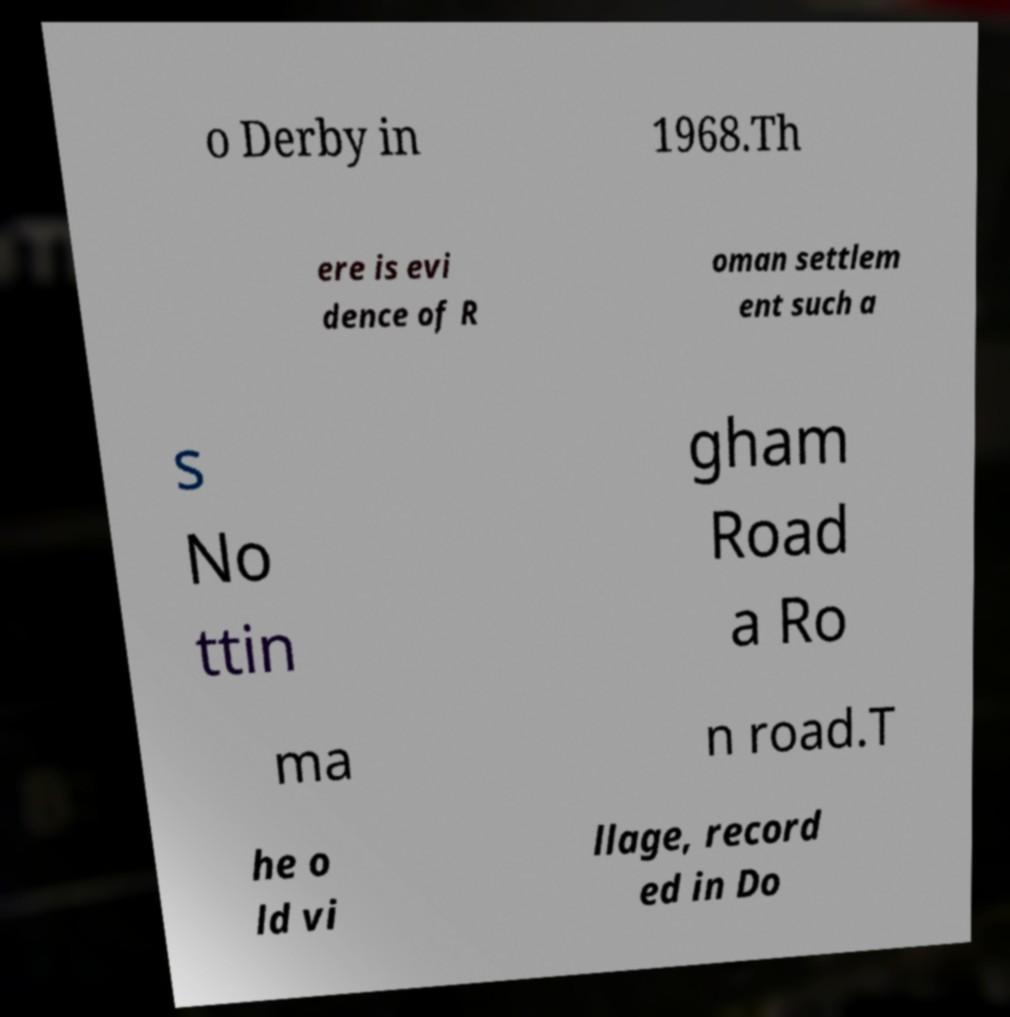For documentation purposes, I need the text within this image transcribed. Could you provide that? o Derby in 1968.Th ere is evi dence of R oman settlem ent such a s No ttin gham Road a Ro ma n road.T he o ld vi llage, record ed in Do 